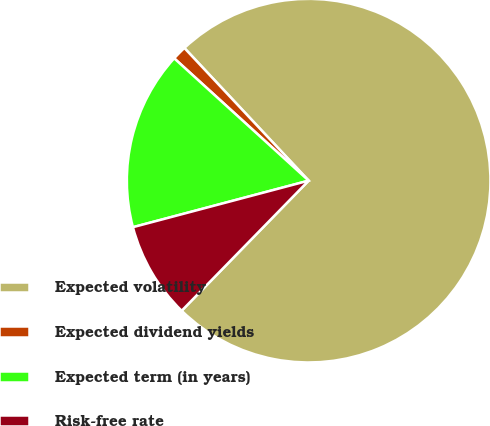Convert chart to OTSL. <chart><loc_0><loc_0><loc_500><loc_500><pie_chart><fcel>Expected volatility<fcel>Expected dividend yields<fcel>Expected term (in years)<fcel>Risk-free rate<nl><fcel>74.29%<fcel>1.27%<fcel>15.87%<fcel>8.57%<nl></chart> 